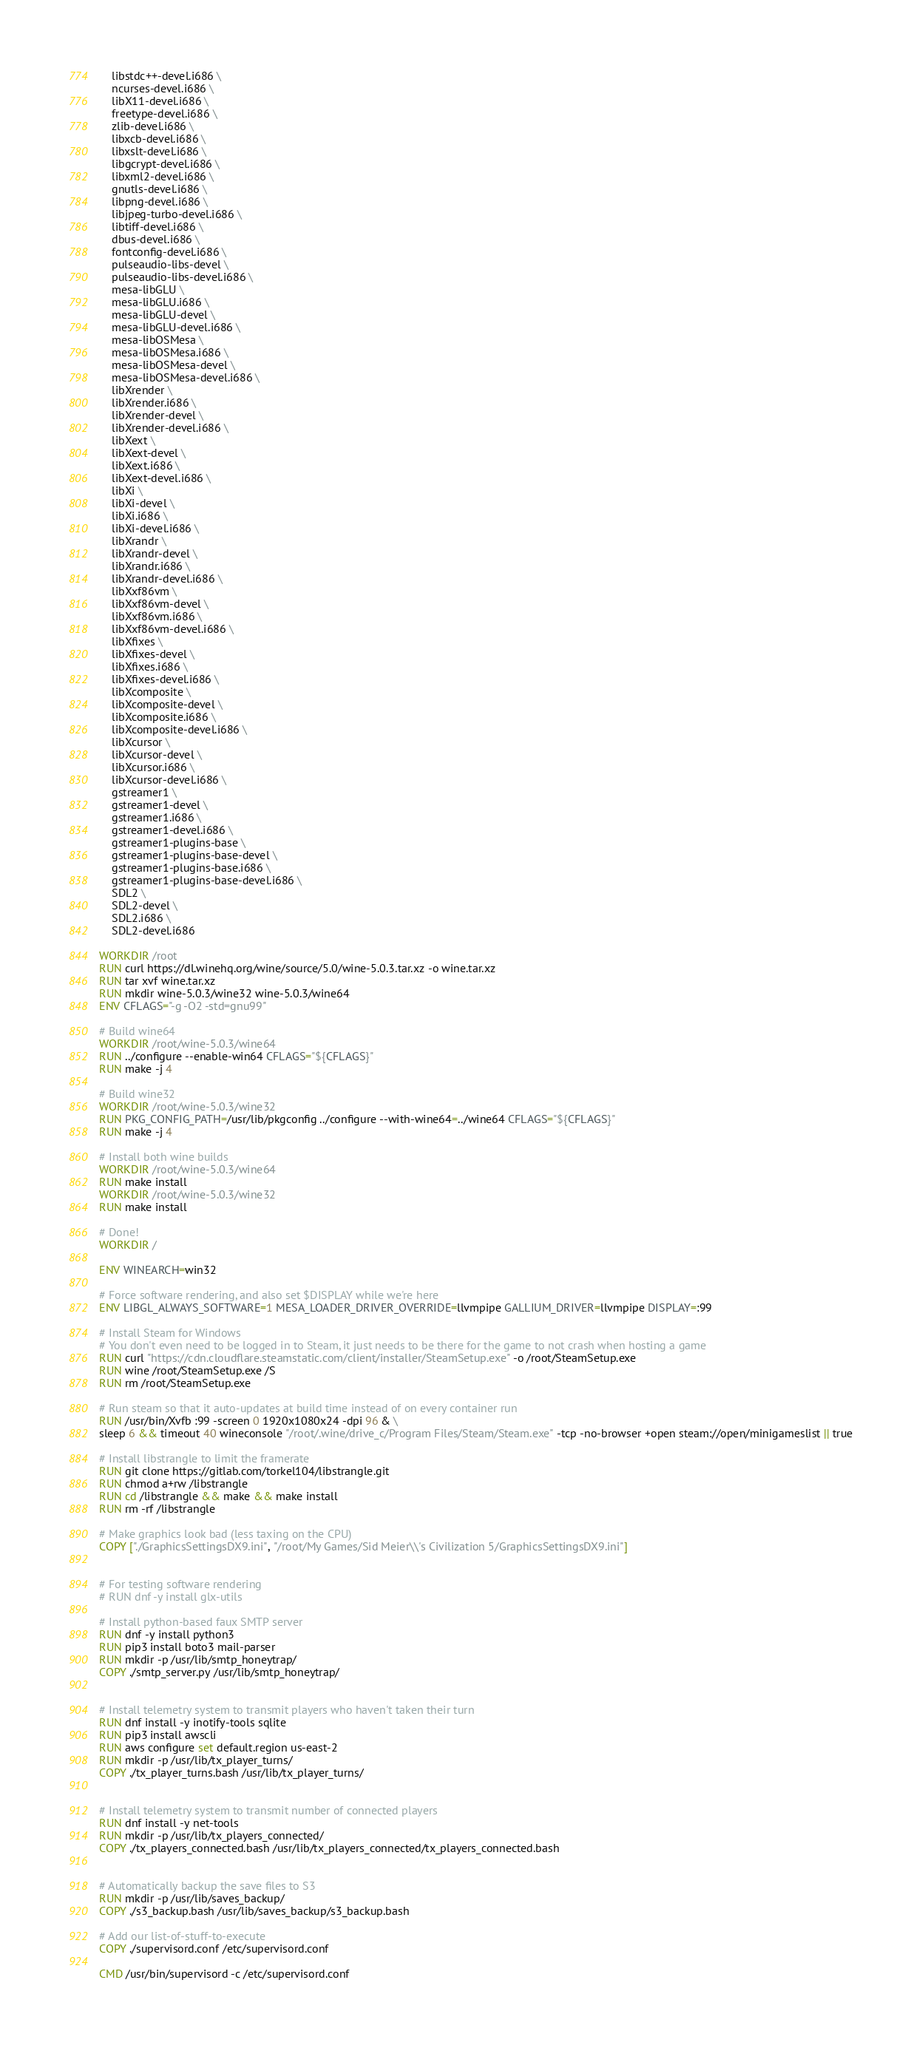Convert code to text. <code><loc_0><loc_0><loc_500><loc_500><_Dockerfile_>    libstdc++-devel.i686 \
    ncurses-devel.i686 \
    libX11-devel.i686 \
    freetype-devel.i686 \
    zlib-devel.i686 \
    libxcb-devel.i686 \
    libxslt-devel.i686 \
    libgcrypt-devel.i686 \
    libxml2-devel.i686 \
    gnutls-devel.i686 \
    libpng-devel.i686 \
    libjpeg-turbo-devel.i686 \
    libtiff-devel.i686 \
    dbus-devel.i686 \
    fontconfig-devel.i686 \
    pulseaudio-libs-devel \
    pulseaudio-libs-devel.i686 \
    mesa-libGLU \
    mesa-libGLU.i686 \
    mesa-libGLU-devel \
    mesa-libGLU-devel.i686 \
    mesa-libOSMesa \
    mesa-libOSMesa.i686 \
    mesa-libOSMesa-devel \
    mesa-libOSMesa-devel.i686 \
    libXrender \
    libXrender.i686 \
    libXrender-devel \
    libXrender-devel.i686 \
    libXext \
    libXext-devel \
    libXext.i686 \
    libXext-devel.i686 \
    libXi \
    libXi-devel \
    libXi.i686 \
    libXi-devel.i686 \
    libXrandr \
    libXrandr-devel \
    libXrandr.i686 \
    libXrandr-devel.i686 \
    libXxf86vm \
    libXxf86vm-devel \
    libXxf86vm.i686 \
    libXxf86vm-devel.i686 \
    libXfixes \
    libXfixes-devel \
    libXfixes.i686 \
    libXfixes-devel.i686 \
    libXcomposite \
    libXcomposite-devel \
    libXcomposite.i686 \
    libXcomposite-devel.i686 \
    libXcursor \
    libXcursor-devel \
    libXcursor.i686 \
    libXcursor-devel.i686 \
    gstreamer1 \
    gstreamer1-devel \
    gstreamer1.i686 \
    gstreamer1-devel.i686 \
    gstreamer1-plugins-base \
    gstreamer1-plugins-base-devel \
    gstreamer1-plugins-base.i686 \
    gstreamer1-plugins-base-devel.i686 \
    SDL2 \
    SDL2-devel \
    SDL2.i686 \
    SDL2-devel.i686

WORKDIR /root
RUN curl https://dl.winehq.org/wine/source/5.0/wine-5.0.3.tar.xz -o wine.tar.xz
RUN tar xvf wine.tar.xz
RUN mkdir wine-5.0.3/wine32 wine-5.0.3/wine64
ENV CFLAGS="-g -O2 -std=gnu99"

# Build wine64
WORKDIR /root/wine-5.0.3/wine64
RUN ../configure --enable-win64 CFLAGS="${CFLAGS}"
RUN make -j 4

# Build wine32
WORKDIR /root/wine-5.0.3/wine32
RUN PKG_CONFIG_PATH=/usr/lib/pkgconfig ../configure --with-wine64=../wine64 CFLAGS="${CFLAGS}"
RUN make -j 4

# Install both wine builds
WORKDIR /root/wine-5.0.3/wine64
RUN make install
WORKDIR /root/wine-5.0.3/wine32
RUN make install

# Done!
WORKDIR /

ENV WINEARCH=win32

# Force software rendering, and also set $DISPLAY while we're here
ENV LIBGL_ALWAYS_SOFTWARE=1 MESA_LOADER_DRIVER_OVERRIDE=llvmpipe GALLIUM_DRIVER=llvmpipe DISPLAY=:99

# Install Steam for Windows
# You don't even need to be logged in to Steam, it just needs to be there for the game to not crash when hosting a game
RUN curl "https://cdn.cloudflare.steamstatic.com/client/installer/SteamSetup.exe" -o /root/SteamSetup.exe
RUN wine /root/SteamSetup.exe /S
RUN rm /root/SteamSetup.exe

# Run steam so that it auto-updates at build time instead of on every container run
RUN /usr/bin/Xvfb :99 -screen 0 1920x1080x24 -dpi 96 & \
sleep 6 && timeout 40 wineconsole "/root/.wine/drive_c/Program Files/Steam/Steam.exe" -tcp -no-browser +open steam://open/minigameslist || true

# Install libstrangle to limit the framerate
RUN git clone https://gitlab.com/torkel104/libstrangle.git
RUN chmod a+rw /libstrangle
RUN cd /libstrangle && make && make install
RUN rm -rf /libstrangle

# Make graphics look bad (less taxing on the CPU)
COPY ["./GraphicsSettingsDX9.ini", "/root/My Games/Sid Meier\\'s Civilization 5/GraphicsSettingsDX9.ini"]


# For testing software rendering
# RUN dnf -y install glx-utils

# Install python-based faux SMTP server
RUN dnf -y install python3
RUN pip3 install boto3 mail-parser
RUN mkdir -p /usr/lib/smtp_honeytrap/
COPY ./smtp_server.py /usr/lib/smtp_honeytrap/


# Install telemetry system to transmit players who haven't taken their turn
RUN dnf install -y inotify-tools sqlite
RUN pip3 install awscli
RUN aws configure set default.region us-east-2
RUN mkdir -p /usr/lib/tx_player_turns/
COPY ./tx_player_turns.bash /usr/lib/tx_player_turns/


# Install telemetry system to transmit number of connected players
RUN dnf install -y net-tools
RUN mkdir -p /usr/lib/tx_players_connected/
COPY ./tx_players_connected.bash /usr/lib/tx_players_connected/tx_players_connected.bash


# Automatically backup the save files to S3
RUN mkdir -p /usr/lib/saves_backup/
COPY ./s3_backup.bash /usr/lib/saves_backup/s3_backup.bash

# Add our list-of-stuff-to-execute
COPY ./supervisord.conf /etc/supervisord.conf

CMD /usr/bin/supervisord -c /etc/supervisord.conf
</code> 